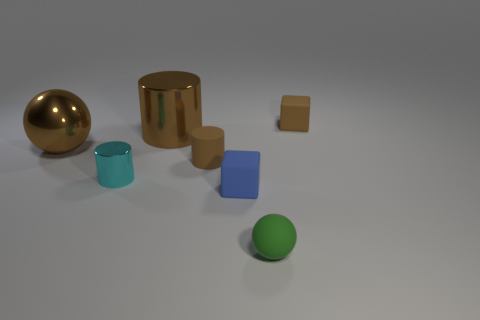What is the material of the large brown thing that is the same shape as the cyan metallic object?
Your response must be concise. Metal. Are there more small matte things in front of the cyan thing than big purple metal cylinders?
Make the answer very short. Yes. Is there any other thing that has the same color as the small matte cylinder?
Offer a very short reply. Yes. There is a green thing that is the same material as the small blue object; what is its shape?
Keep it short and to the point. Sphere. Is the material of the block left of the small green object the same as the green ball?
Ensure brevity in your answer.  Yes. The small object that is the same color as the tiny rubber cylinder is what shape?
Give a very brief answer. Cube. There is a rubber block behind the tiny shiny thing; is it the same color as the ball on the left side of the green matte object?
Provide a short and direct response. Yes. What number of tiny brown matte things are to the left of the green matte sphere and right of the tiny green rubber ball?
Offer a terse response. 0. What material is the brown sphere?
Make the answer very short. Metal. What shape is the green rubber object that is the same size as the blue matte thing?
Your response must be concise. Sphere. 